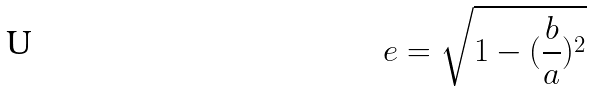<formula> <loc_0><loc_0><loc_500><loc_500>e = \sqrt { 1 - ( \frac { b } { a } ) ^ { 2 } }</formula> 